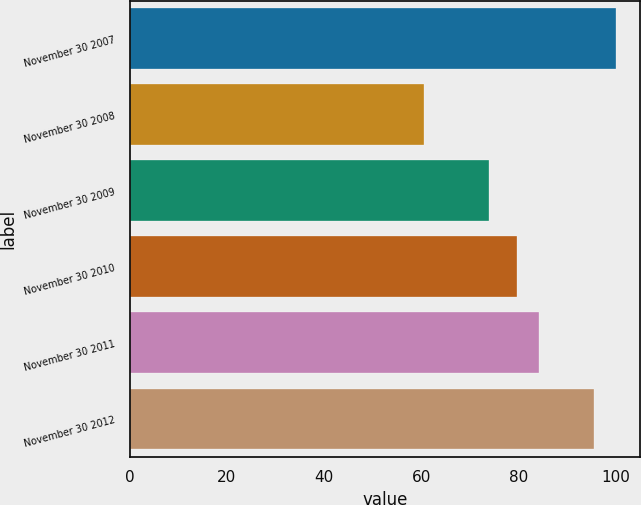Convert chart to OTSL. <chart><loc_0><loc_0><loc_500><loc_500><bar_chart><fcel>November 30 2007<fcel>November 30 2008<fcel>November 30 2009<fcel>November 30 2010<fcel>November 30 2011<fcel>November 30 2012<nl><fcel>100<fcel>60.51<fcel>73.97<fcel>79.71<fcel>84.19<fcel>95.61<nl></chart> 